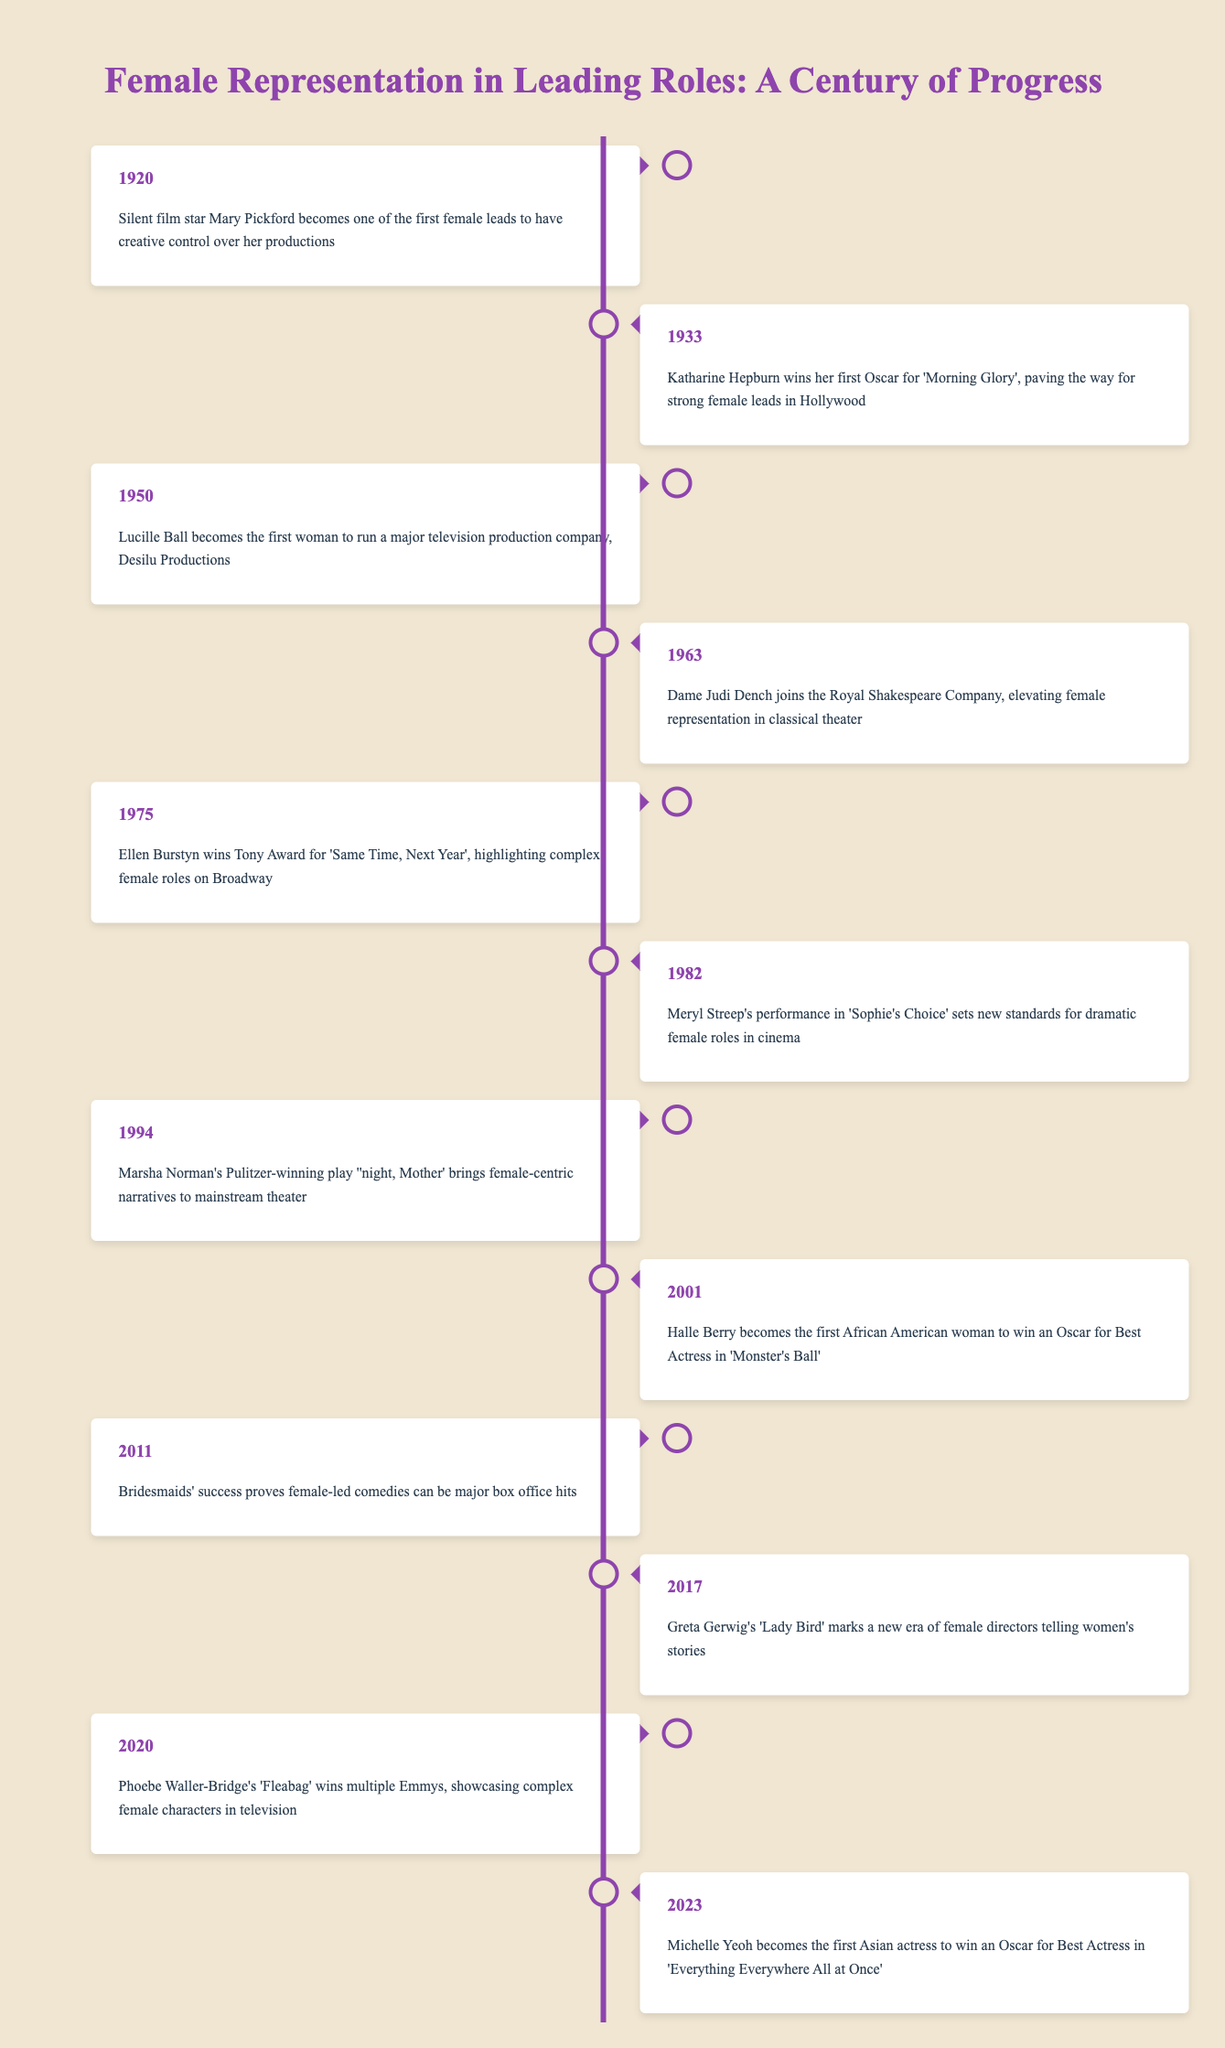What event in 1920 marked a significant achievement in female representation? In 1920, silent film star Mary Pickford became one of the first female leads to have creative control over her productions. This event is clearly noted in the timeline, showcasing an early instance of female empowerment in the film industry.
Answer: Mary Pickford's creative control Which actress won an Oscar in 1933 and for which film? Katharine Hepburn won her first Oscar for 'Morning Glory' in 1933, as indicated in the timeline. This win is significant as it helped pave the way for strong female leads in Hollywood.
Answer: Katharine Hepburn for 'Morning Glory' Was Ellen Burstyn's Tony Award win in 1975 significant for complex female roles? Yes, Ellen Burstyn won the Tony Award for 'Same Time, Next Year' in 1975, which is highlighted in the timeline as a notable moment that emphasized the complexity of female roles on Broadway.
Answer: Yes How many years after Lucille Ball's achievement was Halle Berry's Oscar win? Lucille Ball became the first woman to run a major television production company in 1950, and Halle Berry won her Oscar in 2001. The difference between 2001 and 1950 is 51 years, thus marking a substantial timeframe in female representation.
Answer: 51 years What percentage of the events listed occurred after 2000? There are 5 events listed after 2000: Halle Berry's win in 2001, the success of 'Bridesmaids' in 2011, Greta Gerwig's 'Lady Bird' in 2017, Phoebe Waller-Bridge's 'Fleabag' in 2020, and Michelle Yeoh's Oscar win in 2023. Since there are 12 total events, the percentage is (5/12) * 100 = 41.67%.
Answer: Approximately 41.67% How did the narrative of female representation shift from 1920 to 2023? The timeline reflects a notable evolution in female representation, starting with early creative control by Mary Pickford and evolving through significant Oscar wins for women of color like Halle Berry and Michelle Yeoh. Additionally, the involvement of female directors in telling women's stories gained more prominence in recent years. This points towards increasing visibility and complexity in female narratives over the century.
Answer: Significant evolution in visibility and complexity Which two milestones mark the early and recent achievements of female representation in cinema? The early milestone is Mary Pickford's creative control in 1920 and the recent milestone is Michelle Yeoh becoming the first Asian actress to win an Oscar in 2023. These two events highlight the progression of female representation in cinema across a century.
Answer: Mary Pickford in 1920 and Michelle Yeoh in 2023 Did female-led comedies prove successful at the box office according to the timeline? Yes, the success of 'Bridesmaids' in 2011 is explicitly noted in the timeline as evidence that female-led comedies can be major box office hits, affirming the growing acceptance and popularity of women in leading comedic roles.
Answer: Yes 